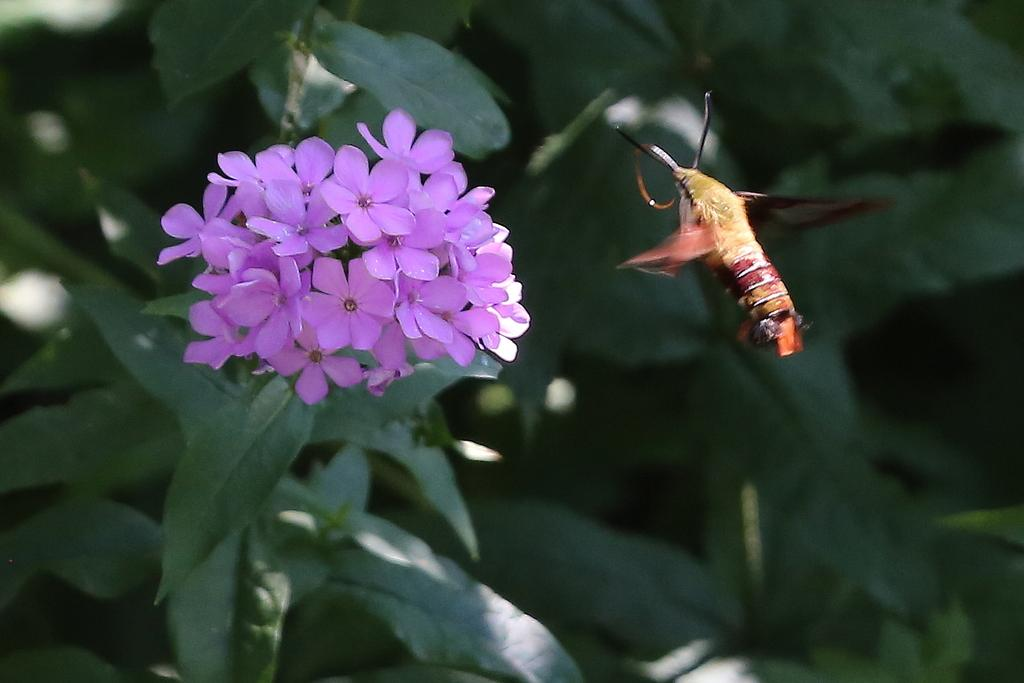What type of plant is on the left side of the image? The plant on the left side of the image has green leaves and pink flowers. What can be seen on the plant in the image? The plant has green leaves and pink flowers. What is present on the right side of the image? There is an insect on the right side of the image. How would you describe the background of the image? The background of the image is blurred. What type of veil is draped over the plant in the image? There is no veil present in the image; the plant has green leaves and pink flowers. What message of hope does the plant convey in the image? The plant does not convey a message of hope in the image; it is simply a plant with green leaves and pink flowers. 